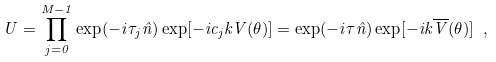<formula> <loc_0><loc_0><loc_500><loc_500>U = \prod _ { j = 0 } ^ { M - 1 } \exp ( - i \tau _ { j } { \hat { n } } ) \exp [ - i c _ { j } k V ( \theta ) ] = \exp ( - i \tau { \hat { n } } ) \exp [ - i k \overline { V } ( \theta ) ] \ ,</formula> 